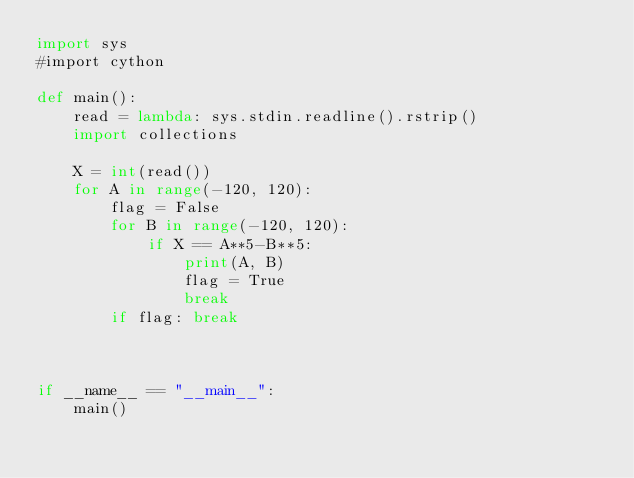Convert code to text. <code><loc_0><loc_0><loc_500><loc_500><_Python_>import sys
#import cython

def main():
    read = lambda: sys.stdin.readline().rstrip()
    import collections
    
    X = int(read())
    for A in range(-120, 120):
        flag = False
        for B in range(-120, 120):
            if X == A**5-B**5:
                print(A, B)
                flag = True
                break
        if flag: break
    


if __name__ == "__main__":
    main()</code> 